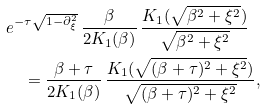Convert formula to latex. <formula><loc_0><loc_0><loc_500><loc_500>& e ^ { - \tau \sqrt { 1 - \partial _ { \xi } ^ { 2 } } } \, \frac { \beta } { 2 K _ { 1 } ( \beta ) } \, \frac { K _ { 1 } ( \sqrt { \beta ^ { 2 } + \xi ^ { 2 } } ) } { \sqrt { \beta ^ { 2 } + \xi ^ { 2 } } } \\ & \quad = \frac { \beta + \tau } { 2 K _ { 1 } ( \beta ) } \, \frac { K _ { 1 } ( \sqrt { ( \beta + \tau ) ^ { 2 } + \xi ^ { 2 } } ) } { \sqrt { ( \beta + \tau ) ^ { 2 } + \xi ^ { 2 } } } ,</formula> 